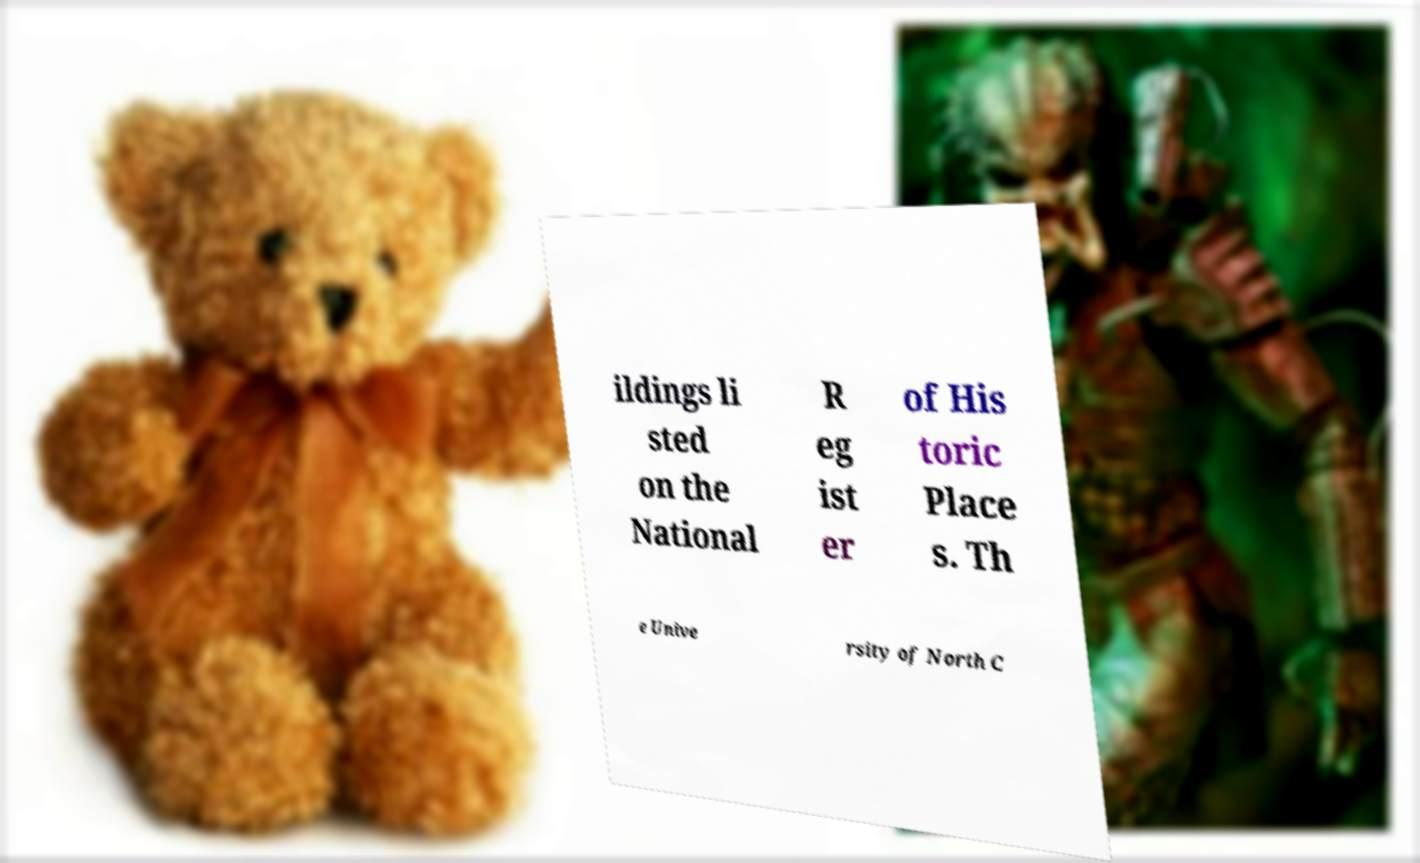I need the written content from this picture converted into text. Can you do that? ildings li sted on the National R eg ist er of His toric Place s. Th e Unive rsity of North C 